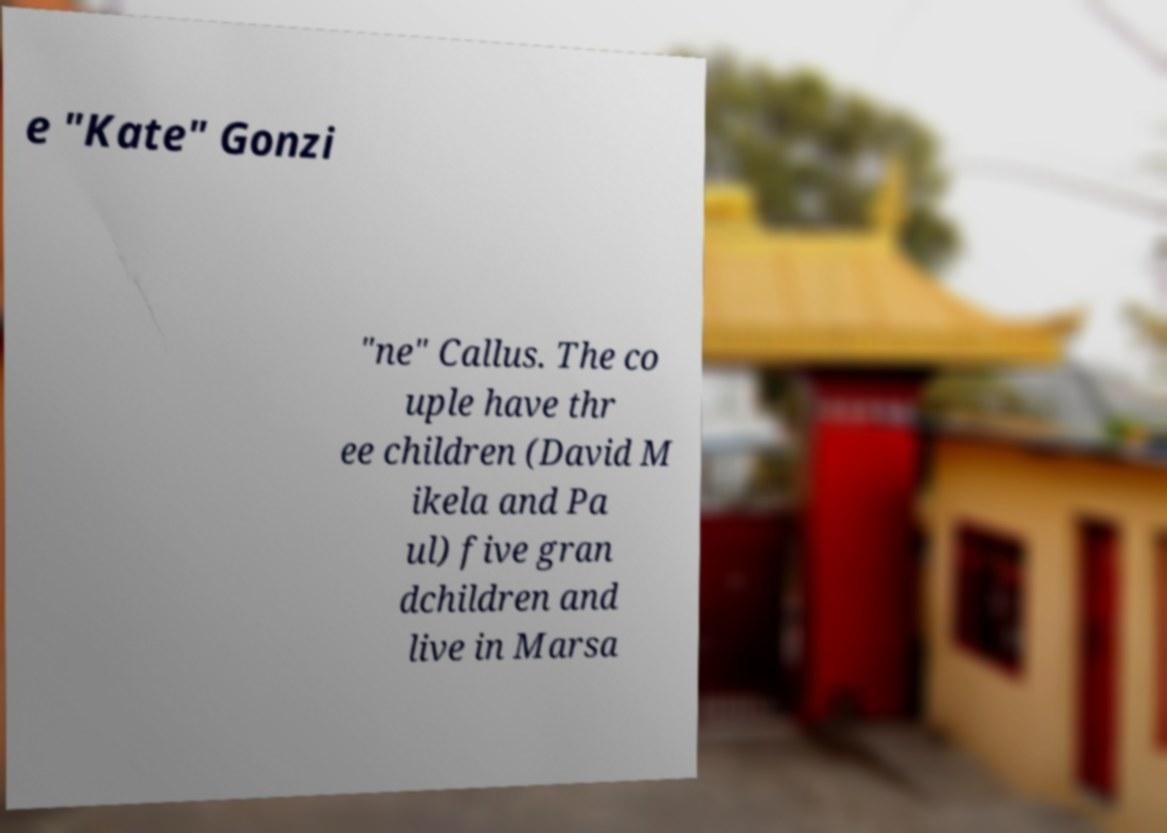I need the written content from this picture converted into text. Can you do that? e "Kate" Gonzi "ne" Callus. The co uple have thr ee children (David M ikela and Pa ul) five gran dchildren and live in Marsa 